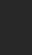<code> <loc_0><loc_0><loc_500><loc_500><_C_>
</code> 